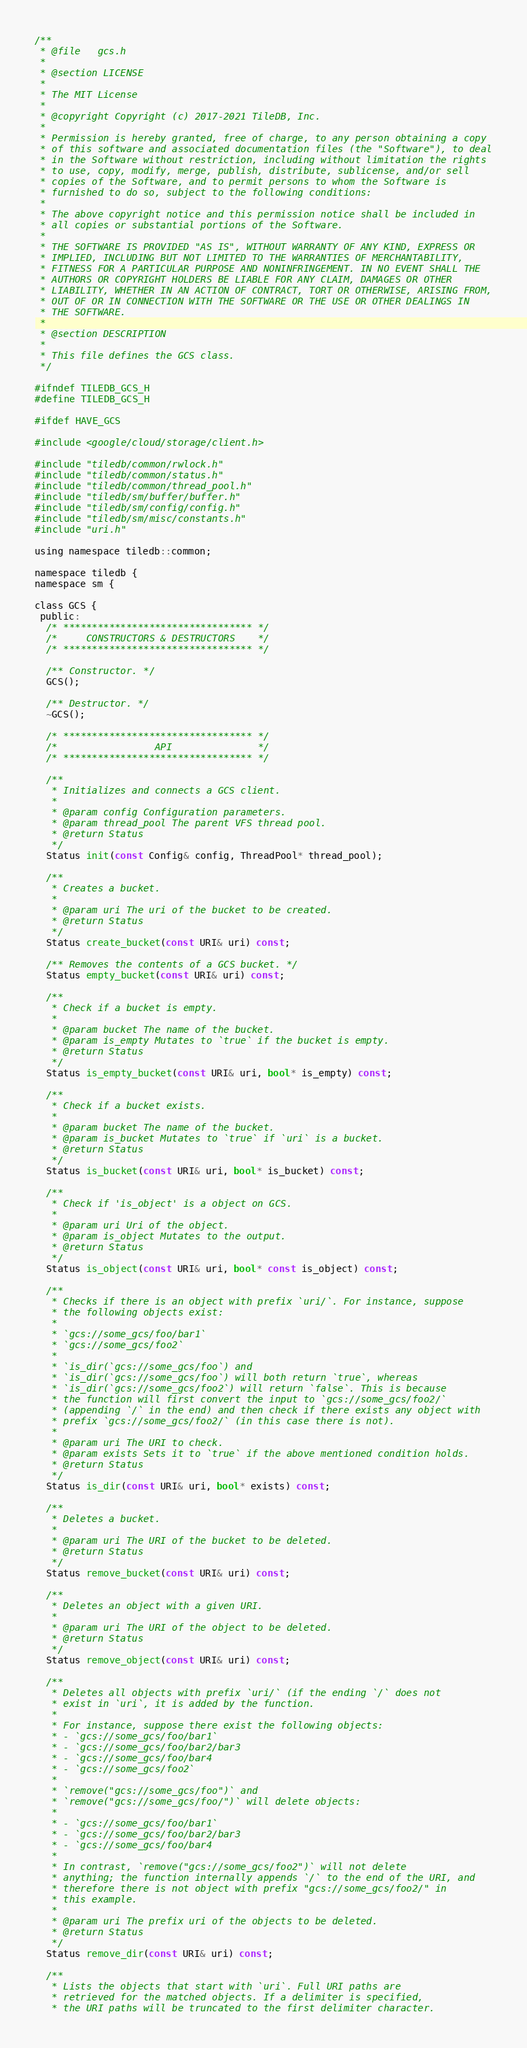Convert code to text. <code><loc_0><loc_0><loc_500><loc_500><_C_>/**
 * @file   gcs.h
 *
 * @section LICENSE
 *
 * The MIT License
 *
 * @copyright Copyright (c) 2017-2021 TileDB, Inc.
 *
 * Permission is hereby granted, free of charge, to any person obtaining a copy
 * of this software and associated documentation files (the "Software"), to deal
 * in the Software without restriction, including without limitation the rights
 * to use, copy, modify, merge, publish, distribute, sublicense, and/or sell
 * copies of the Software, and to permit persons to whom the Software is
 * furnished to do so, subject to the following conditions:
 *
 * The above copyright notice and this permission notice shall be included in
 * all copies or substantial portions of the Software.
 *
 * THE SOFTWARE IS PROVIDED "AS IS", WITHOUT WARRANTY OF ANY KIND, EXPRESS OR
 * IMPLIED, INCLUDING BUT NOT LIMITED TO THE WARRANTIES OF MERCHANTABILITY,
 * FITNESS FOR A PARTICULAR PURPOSE AND NONINFRINGEMENT. IN NO EVENT SHALL THE
 * AUTHORS OR COPYRIGHT HOLDERS BE LIABLE FOR ANY CLAIM, DAMAGES OR OTHER
 * LIABILITY, WHETHER IN AN ACTION OF CONTRACT, TORT OR OTHERWISE, ARISING FROM,
 * OUT OF OR IN CONNECTION WITH THE SOFTWARE OR THE USE OR OTHER DEALINGS IN
 * THE SOFTWARE.
 *
 * @section DESCRIPTION
 *
 * This file defines the GCS class.
 */

#ifndef TILEDB_GCS_H
#define TILEDB_GCS_H

#ifdef HAVE_GCS

#include <google/cloud/storage/client.h>

#include "tiledb/common/rwlock.h"
#include "tiledb/common/status.h"
#include "tiledb/common/thread_pool.h"
#include "tiledb/sm/buffer/buffer.h"
#include "tiledb/sm/config/config.h"
#include "tiledb/sm/misc/constants.h"
#include "uri.h"

using namespace tiledb::common;

namespace tiledb {
namespace sm {

class GCS {
 public:
  /* ********************************* */
  /*     CONSTRUCTORS & DESTRUCTORS    */
  /* ********************************* */

  /** Constructor. */
  GCS();

  /** Destructor. */
  ~GCS();

  /* ********************************* */
  /*                 API               */
  /* ********************************* */

  /**
   * Initializes and connects a GCS client.
   *
   * @param config Configuration parameters.
   * @param thread_pool The parent VFS thread pool.
   * @return Status
   */
  Status init(const Config& config, ThreadPool* thread_pool);

  /**
   * Creates a bucket.
   *
   * @param uri The uri of the bucket to be created.
   * @return Status
   */
  Status create_bucket(const URI& uri) const;

  /** Removes the contents of a GCS bucket. */
  Status empty_bucket(const URI& uri) const;

  /**
   * Check if a bucket is empty.
   *
   * @param bucket The name of the bucket.
   * @param is_empty Mutates to `true` if the bucket is empty.
   * @return Status
   */
  Status is_empty_bucket(const URI& uri, bool* is_empty) const;

  /**
   * Check if a bucket exists.
   *
   * @param bucket The name of the bucket.
   * @param is_bucket Mutates to `true` if `uri` is a bucket.
   * @return Status
   */
  Status is_bucket(const URI& uri, bool* is_bucket) const;

  /**
   * Check if 'is_object' is a object on GCS.
   *
   * @param uri Uri of the object.
   * @param is_object Mutates to the output.
   * @return Status
   */
  Status is_object(const URI& uri, bool* const is_object) const;

  /**
   * Checks if there is an object with prefix `uri/`. For instance, suppose
   * the following objects exist:
   *
   * `gcs://some_gcs/foo/bar1`
   * `gcs://some_gcs/foo2`
   *
   * `is_dir(`gcs://some_gcs/foo`) and
   * `is_dir(`gcs://some_gcs/foo`) will both return `true`, whereas
   * `is_dir(`gcs://some_gcs/foo2`) will return `false`. This is because
   * the function will first convert the input to `gcs://some_gcs/foo2/`
   * (appending `/` in the end) and then check if there exists any object with
   * prefix `gcs://some_gcs/foo2/` (in this case there is not).
   *
   * @param uri The URI to check.
   * @param exists Sets it to `true` if the above mentioned condition holds.
   * @return Status
   */
  Status is_dir(const URI& uri, bool* exists) const;

  /**
   * Deletes a bucket.
   *
   * @param uri The URI of the bucket to be deleted.
   * @return Status
   */
  Status remove_bucket(const URI& uri) const;

  /**
   * Deletes an object with a given URI.
   *
   * @param uri The URI of the object to be deleted.
   * @return Status
   */
  Status remove_object(const URI& uri) const;

  /**
   * Deletes all objects with prefix `uri/` (if the ending `/` does not
   * exist in `uri`, it is added by the function.
   *
   * For instance, suppose there exist the following objects:
   * - `gcs://some_gcs/foo/bar1`
   * - `gcs://some_gcs/foo/bar2/bar3
   * - `gcs://some_gcs/foo/bar4
   * - `gcs://some_gcs/foo2`
   *
   * `remove("gcs://some_gcs/foo")` and
   * `remove("gcs://some_gcs/foo/")` will delete objects:
   *
   * - `gcs://some_gcs/foo/bar1`
   * - `gcs://some_gcs/foo/bar2/bar3
   * - `gcs://some_gcs/foo/bar4
   *
   * In contrast, `remove("gcs://some_gcs/foo2")` will not delete
   * anything; the function internally appends `/` to the end of the URI, and
   * therefore there is not object with prefix "gcs://some_gcs/foo2/" in
   * this example.
   *
   * @param uri The prefix uri of the objects to be deleted.
   * @return Status
   */
  Status remove_dir(const URI& uri) const;

  /**
   * Lists the objects that start with `uri`. Full URI paths are
   * retrieved for the matched objects. If a delimiter is specified,
   * the URI paths will be truncated to the first delimiter character.</code> 